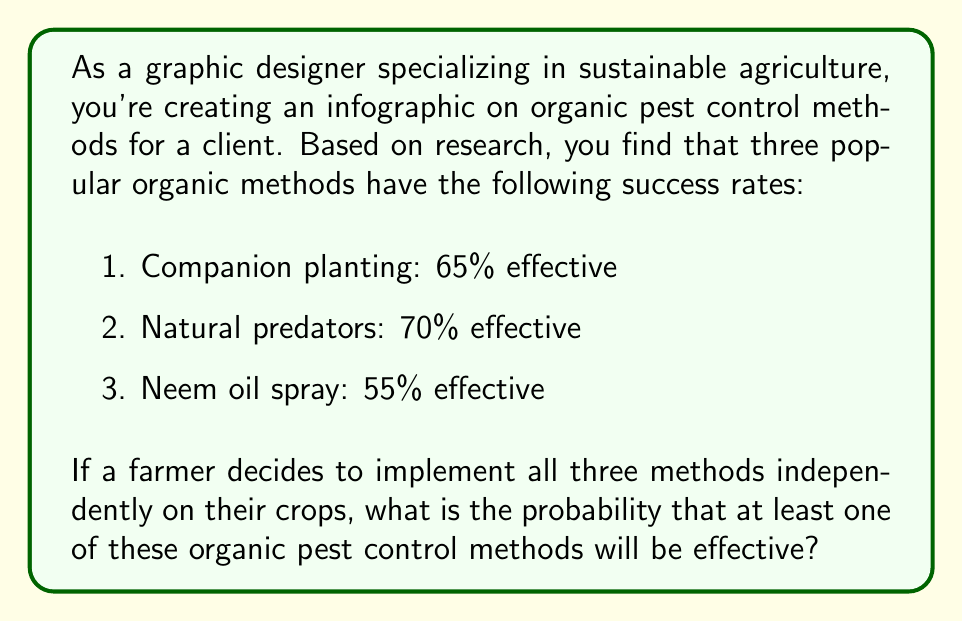Show me your answer to this math problem. To solve this problem, we'll use the concept of probability of at least one event occurring, which is the complement of the probability that none of the events occur.

Let's define our events:
A: Companion planting is effective
B: Natural predators are effective
C: Neem oil spray is effective

We're given:
P(A) = 0.65
P(B) = 0.70
P(C) = 0.55

We want to find P(at least one method is effective) = 1 - P(no method is effective)

P(no method is effective) = P(A' ∩ B' ∩ C')

Since the methods are implemented independently, we can multiply the probabilities:

P(A' ∩ B' ∩ C') = P(A') × P(B') × P(C')

P(A') = 1 - P(A) = 1 - 0.65 = 0.35
P(B') = 1 - P(B) = 1 - 0.70 = 0.30
P(C') = 1 - P(C) = 1 - 0.55 = 0.45

Now, let's calculate:

P(no method is effective) = 0.35 × 0.30 × 0.45 = 0.04725

Therefore:

P(at least one method is effective) = 1 - P(no method is effective)
                                    = 1 - 0.04725
                                    = 0.95275

We can express this as a percentage: 0.95275 × 100% = 95.275%
Answer: The probability that at least one of these organic pest control methods will be effective is approximately 95.28% or 0.9528. 